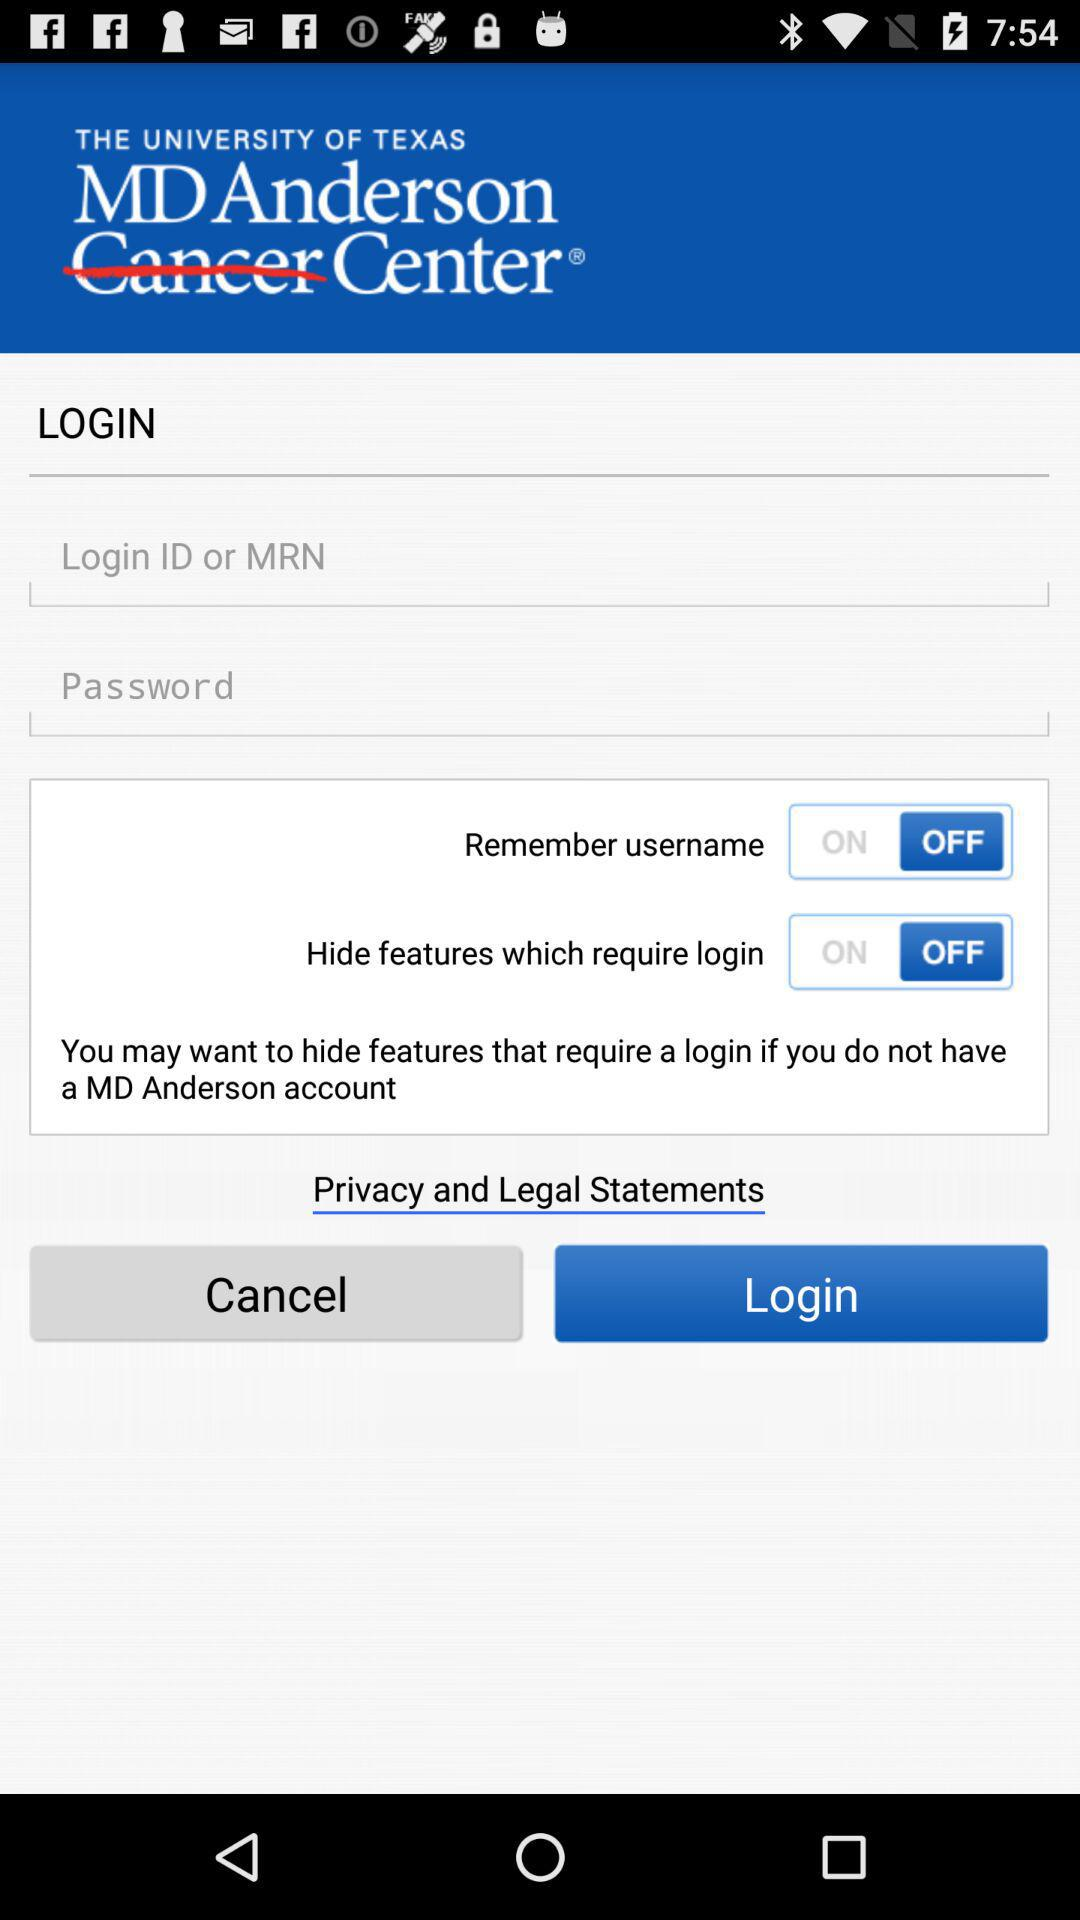How many login-related items are there on this screen?
Answer the question using a single word or phrase. 4 